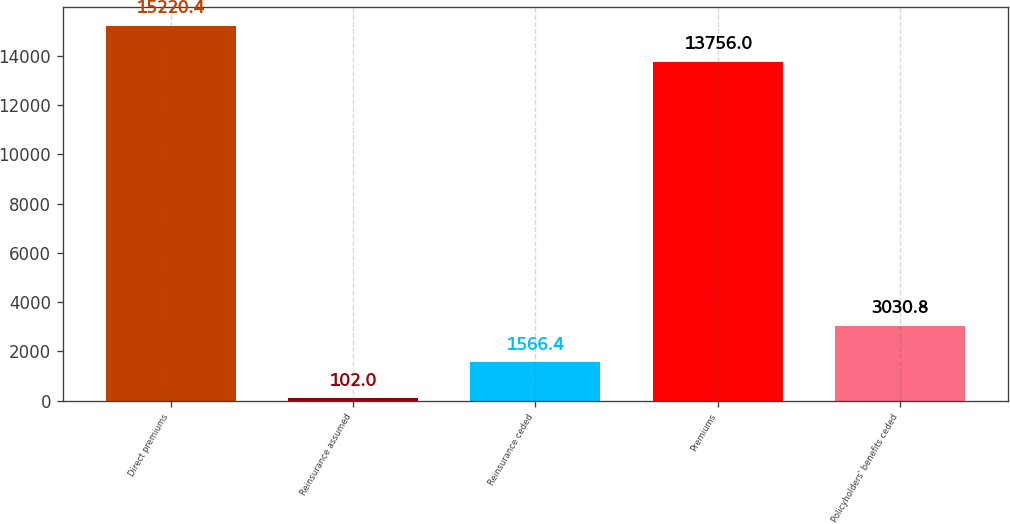Convert chart. <chart><loc_0><loc_0><loc_500><loc_500><bar_chart><fcel>Direct premiums<fcel>Reinsurance assumed<fcel>Reinsurance ceded<fcel>Premiums<fcel>Policyholders' benefits ceded<nl><fcel>15220.4<fcel>102<fcel>1566.4<fcel>13756<fcel>3030.8<nl></chart> 